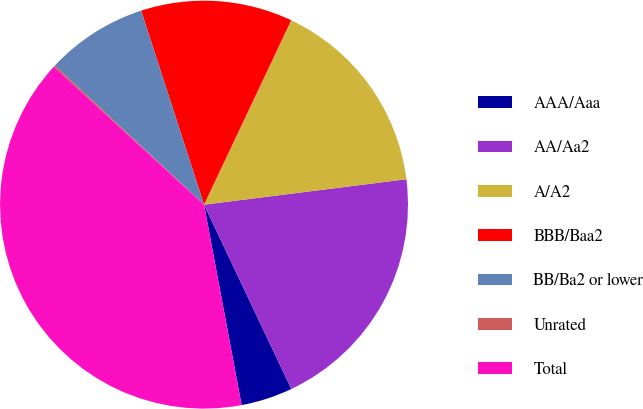<chart> <loc_0><loc_0><loc_500><loc_500><pie_chart><fcel>AAA/Aaa<fcel>AA/Aa2<fcel>A/A2<fcel>BBB/Baa2<fcel>BB/Ba2 or lower<fcel>Unrated<fcel>Total<nl><fcel>4.09%<fcel>19.95%<fcel>15.98%<fcel>12.02%<fcel>8.06%<fcel>0.13%<fcel>39.77%<nl></chart> 